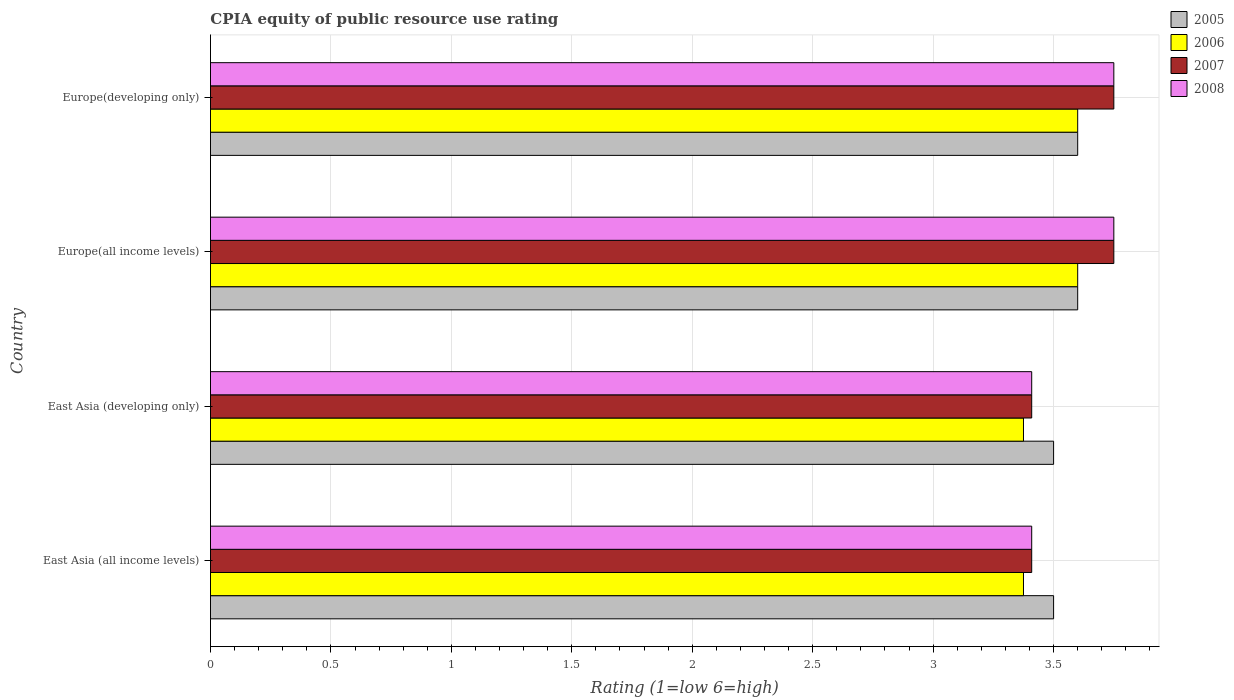How many groups of bars are there?
Ensure brevity in your answer.  4. How many bars are there on the 2nd tick from the bottom?
Your response must be concise. 4. What is the label of the 2nd group of bars from the top?
Your answer should be compact. Europe(all income levels). Across all countries, what is the minimum CPIA rating in 2005?
Ensure brevity in your answer.  3.5. In which country was the CPIA rating in 2005 maximum?
Provide a succinct answer. Europe(all income levels). In which country was the CPIA rating in 2006 minimum?
Your answer should be very brief. East Asia (all income levels). What is the total CPIA rating in 2007 in the graph?
Your answer should be very brief. 14.32. What is the difference between the CPIA rating in 2008 in Europe(all income levels) and that in Europe(developing only)?
Ensure brevity in your answer.  0. What is the average CPIA rating in 2008 per country?
Offer a terse response. 3.58. In how many countries, is the CPIA rating in 2005 greater than 1.9 ?
Your response must be concise. 4. What is the ratio of the CPIA rating in 2007 in East Asia (all income levels) to that in Europe(developing only)?
Keep it short and to the point. 0.91. Is the CPIA rating in 2005 in East Asia (all income levels) less than that in Europe(developing only)?
Your answer should be very brief. Yes. What is the difference between the highest and the second highest CPIA rating in 2005?
Your response must be concise. 0. What is the difference between the highest and the lowest CPIA rating in 2008?
Provide a short and direct response. 0.34. In how many countries, is the CPIA rating in 2006 greater than the average CPIA rating in 2006 taken over all countries?
Your answer should be very brief. 2. Is it the case that in every country, the sum of the CPIA rating in 2007 and CPIA rating in 2006 is greater than the sum of CPIA rating in 2008 and CPIA rating in 2005?
Offer a terse response. No. What does the 3rd bar from the bottom in Europe(all income levels) represents?
Keep it short and to the point. 2007. Is it the case that in every country, the sum of the CPIA rating in 2005 and CPIA rating in 2008 is greater than the CPIA rating in 2006?
Provide a succinct answer. Yes. Are all the bars in the graph horizontal?
Offer a terse response. Yes. What is the difference between two consecutive major ticks on the X-axis?
Provide a succinct answer. 0.5. Are the values on the major ticks of X-axis written in scientific E-notation?
Your answer should be very brief. No. Does the graph contain any zero values?
Your response must be concise. No. How many legend labels are there?
Offer a very short reply. 4. What is the title of the graph?
Your response must be concise. CPIA equity of public resource use rating. What is the label or title of the X-axis?
Offer a terse response. Rating (1=low 6=high). What is the Rating (1=low 6=high) of 2006 in East Asia (all income levels)?
Your response must be concise. 3.38. What is the Rating (1=low 6=high) of 2007 in East Asia (all income levels)?
Your answer should be very brief. 3.41. What is the Rating (1=low 6=high) of 2008 in East Asia (all income levels)?
Offer a very short reply. 3.41. What is the Rating (1=low 6=high) in 2006 in East Asia (developing only)?
Make the answer very short. 3.38. What is the Rating (1=low 6=high) in 2007 in East Asia (developing only)?
Ensure brevity in your answer.  3.41. What is the Rating (1=low 6=high) of 2008 in East Asia (developing only)?
Your answer should be compact. 3.41. What is the Rating (1=low 6=high) of 2006 in Europe(all income levels)?
Give a very brief answer. 3.6. What is the Rating (1=low 6=high) of 2007 in Europe(all income levels)?
Make the answer very short. 3.75. What is the Rating (1=low 6=high) in 2008 in Europe(all income levels)?
Give a very brief answer. 3.75. What is the Rating (1=low 6=high) of 2007 in Europe(developing only)?
Offer a terse response. 3.75. What is the Rating (1=low 6=high) in 2008 in Europe(developing only)?
Your answer should be compact. 3.75. Across all countries, what is the maximum Rating (1=low 6=high) in 2006?
Give a very brief answer. 3.6. Across all countries, what is the maximum Rating (1=low 6=high) in 2007?
Give a very brief answer. 3.75. Across all countries, what is the maximum Rating (1=low 6=high) of 2008?
Keep it short and to the point. 3.75. Across all countries, what is the minimum Rating (1=low 6=high) of 2006?
Keep it short and to the point. 3.38. Across all countries, what is the minimum Rating (1=low 6=high) of 2007?
Your response must be concise. 3.41. Across all countries, what is the minimum Rating (1=low 6=high) of 2008?
Ensure brevity in your answer.  3.41. What is the total Rating (1=low 6=high) of 2005 in the graph?
Keep it short and to the point. 14.2. What is the total Rating (1=low 6=high) of 2006 in the graph?
Provide a short and direct response. 13.95. What is the total Rating (1=low 6=high) in 2007 in the graph?
Your response must be concise. 14.32. What is the total Rating (1=low 6=high) in 2008 in the graph?
Ensure brevity in your answer.  14.32. What is the difference between the Rating (1=low 6=high) of 2006 in East Asia (all income levels) and that in Europe(all income levels)?
Give a very brief answer. -0.23. What is the difference between the Rating (1=low 6=high) in 2007 in East Asia (all income levels) and that in Europe(all income levels)?
Provide a short and direct response. -0.34. What is the difference between the Rating (1=low 6=high) of 2008 in East Asia (all income levels) and that in Europe(all income levels)?
Offer a very short reply. -0.34. What is the difference between the Rating (1=low 6=high) in 2006 in East Asia (all income levels) and that in Europe(developing only)?
Your answer should be compact. -0.23. What is the difference between the Rating (1=low 6=high) of 2007 in East Asia (all income levels) and that in Europe(developing only)?
Your answer should be very brief. -0.34. What is the difference between the Rating (1=low 6=high) of 2008 in East Asia (all income levels) and that in Europe(developing only)?
Offer a terse response. -0.34. What is the difference between the Rating (1=low 6=high) of 2005 in East Asia (developing only) and that in Europe(all income levels)?
Make the answer very short. -0.1. What is the difference between the Rating (1=low 6=high) of 2006 in East Asia (developing only) and that in Europe(all income levels)?
Make the answer very short. -0.23. What is the difference between the Rating (1=low 6=high) of 2007 in East Asia (developing only) and that in Europe(all income levels)?
Your answer should be compact. -0.34. What is the difference between the Rating (1=low 6=high) in 2008 in East Asia (developing only) and that in Europe(all income levels)?
Your answer should be very brief. -0.34. What is the difference between the Rating (1=low 6=high) of 2006 in East Asia (developing only) and that in Europe(developing only)?
Your response must be concise. -0.23. What is the difference between the Rating (1=low 6=high) in 2007 in East Asia (developing only) and that in Europe(developing only)?
Make the answer very short. -0.34. What is the difference between the Rating (1=low 6=high) of 2008 in East Asia (developing only) and that in Europe(developing only)?
Give a very brief answer. -0.34. What is the difference between the Rating (1=low 6=high) in 2005 in Europe(all income levels) and that in Europe(developing only)?
Keep it short and to the point. 0. What is the difference between the Rating (1=low 6=high) of 2007 in Europe(all income levels) and that in Europe(developing only)?
Ensure brevity in your answer.  0. What is the difference between the Rating (1=low 6=high) of 2005 in East Asia (all income levels) and the Rating (1=low 6=high) of 2007 in East Asia (developing only)?
Offer a very short reply. 0.09. What is the difference between the Rating (1=low 6=high) in 2005 in East Asia (all income levels) and the Rating (1=low 6=high) in 2008 in East Asia (developing only)?
Your response must be concise. 0.09. What is the difference between the Rating (1=low 6=high) of 2006 in East Asia (all income levels) and the Rating (1=low 6=high) of 2007 in East Asia (developing only)?
Provide a succinct answer. -0.03. What is the difference between the Rating (1=low 6=high) in 2006 in East Asia (all income levels) and the Rating (1=low 6=high) in 2008 in East Asia (developing only)?
Provide a short and direct response. -0.03. What is the difference between the Rating (1=low 6=high) of 2007 in East Asia (all income levels) and the Rating (1=low 6=high) of 2008 in East Asia (developing only)?
Your answer should be very brief. 0. What is the difference between the Rating (1=low 6=high) of 2005 in East Asia (all income levels) and the Rating (1=low 6=high) of 2006 in Europe(all income levels)?
Ensure brevity in your answer.  -0.1. What is the difference between the Rating (1=low 6=high) of 2005 in East Asia (all income levels) and the Rating (1=low 6=high) of 2007 in Europe(all income levels)?
Ensure brevity in your answer.  -0.25. What is the difference between the Rating (1=low 6=high) of 2006 in East Asia (all income levels) and the Rating (1=low 6=high) of 2007 in Europe(all income levels)?
Your response must be concise. -0.38. What is the difference between the Rating (1=low 6=high) of 2006 in East Asia (all income levels) and the Rating (1=low 6=high) of 2008 in Europe(all income levels)?
Your answer should be very brief. -0.38. What is the difference between the Rating (1=low 6=high) of 2007 in East Asia (all income levels) and the Rating (1=low 6=high) of 2008 in Europe(all income levels)?
Keep it short and to the point. -0.34. What is the difference between the Rating (1=low 6=high) of 2006 in East Asia (all income levels) and the Rating (1=low 6=high) of 2007 in Europe(developing only)?
Give a very brief answer. -0.38. What is the difference between the Rating (1=low 6=high) of 2006 in East Asia (all income levels) and the Rating (1=low 6=high) of 2008 in Europe(developing only)?
Your answer should be compact. -0.38. What is the difference between the Rating (1=low 6=high) in 2007 in East Asia (all income levels) and the Rating (1=low 6=high) in 2008 in Europe(developing only)?
Make the answer very short. -0.34. What is the difference between the Rating (1=low 6=high) of 2005 in East Asia (developing only) and the Rating (1=low 6=high) of 2006 in Europe(all income levels)?
Your answer should be compact. -0.1. What is the difference between the Rating (1=low 6=high) of 2005 in East Asia (developing only) and the Rating (1=low 6=high) of 2007 in Europe(all income levels)?
Ensure brevity in your answer.  -0.25. What is the difference between the Rating (1=low 6=high) of 2006 in East Asia (developing only) and the Rating (1=low 6=high) of 2007 in Europe(all income levels)?
Give a very brief answer. -0.38. What is the difference between the Rating (1=low 6=high) in 2006 in East Asia (developing only) and the Rating (1=low 6=high) in 2008 in Europe(all income levels)?
Your answer should be compact. -0.38. What is the difference between the Rating (1=low 6=high) of 2007 in East Asia (developing only) and the Rating (1=low 6=high) of 2008 in Europe(all income levels)?
Your answer should be very brief. -0.34. What is the difference between the Rating (1=low 6=high) in 2005 in East Asia (developing only) and the Rating (1=low 6=high) in 2006 in Europe(developing only)?
Your answer should be compact. -0.1. What is the difference between the Rating (1=low 6=high) in 2006 in East Asia (developing only) and the Rating (1=low 6=high) in 2007 in Europe(developing only)?
Provide a short and direct response. -0.38. What is the difference between the Rating (1=low 6=high) in 2006 in East Asia (developing only) and the Rating (1=low 6=high) in 2008 in Europe(developing only)?
Provide a succinct answer. -0.38. What is the difference between the Rating (1=low 6=high) in 2007 in East Asia (developing only) and the Rating (1=low 6=high) in 2008 in Europe(developing only)?
Your response must be concise. -0.34. What is the difference between the Rating (1=low 6=high) of 2006 in Europe(all income levels) and the Rating (1=low 6=high) of 2007 in Europe(developing only)?
Provide a short and direct response. -0.15. What is the difference between the Rating (1=low 6=high) of 2006 in Europe(all income levels) and the Rating (1=low 6=high) of 2008 in Europe(developing only)?
Your answer should be compact. -0.15. What is the average Rating (1=low 6=high) of 2005 per country?
Offer a very short reply. 3.55. What is the average Rating (1=low 6=high) of 2006 per country?
Provide a short and direct response. 3.49. What is the average Rating (1=low 6=high) in 2007 per country?
Offer a terse response. 3.58. What is the average Rating (1=low 6=high) in 2008 per country?
Your answer should be compact. 3.58. What is the difference between the Rating (1=low 6=high) in 2005 and Rating (1=low 6=high) in 2007 in East Asia (all income levels)?
Your answer should be very brief. 0.09. What is the difference between the Rating (1=low 6=high) of 2005 and Rating (1=low 6=high) of 2008 in East Asia (all income levels)?
Your answer should be compact. 0.09. What is the difference between the Rating (1=low 6=high) of 2006 and Rating (1=low 6=high) of 2007 in East Asia (all income levels)?
Offer a very short reply. -0.03. What is the difference between the Rating (1=low 6=high) in 2006 and Rating (1=low 6=high) in 2008 in East Asia (all income levels)?
Your answer should be very brief. -0.03. What is the difference between the Rating (1=low 6=high) in 2005 and Rating (1=low 6=high) in 2007 in East Asia (developing only)?
Make the answer very short. 0.09. What is the difference between the Rating (1=low 6=high) in 2005 and Rating (1=low 6=high) in 2008 in East Asia (developing only)?
Make the answer very short. 0.09. What is the difference between the Rating (1=low 6=high) in 2006 and Rating (1=low 6=high) in 2007 in East Asia (developing only)?
Provide a short and direct response. -0.03. What is the difference between the Rating (1=low 6=high) of 2006 and Rating (1=low 6=high) of 2008 in East Asia (developing only)?
Give a very brief answer. -0.03. What is the difference between the Rating (1=low 6=high) of 2005 and Rating (1=low 6=high) of 2007 in Europe(all income levels)?
Provide a succinct answer. -0.15. What is the difference between the Rating (1=low 6=high) in 2005 and Rating (1=low 6=high) in 2008 in Europe(all income levels)?
Offer a very short reply. -0.15. What is the difference between the Rating (1=low 6=high) in 2006 and Rating (1=low 6=high) in 2007 in Europe(all income levels)?
Offer a terse response. -0.15. What is the difference between the Rating (1=low 6=high) of 2005 and Rating (1=low 6=high) of 2006 in Europe(developing only)?
Your answer should be very brief. 0. What is the difference between the Rating (1=low 6=high) of 2005 and Rating (1=low 6=high) of 2007 in Europe(developing only)?
Your answer should be very brief. -0.15. What is the difference between the Rating (1=low 6=high) of 2007 and Rating (1=low 6=high) of 2008 in Europe(developing only)?
Offer a very short reply. 0. What is the ratio of the Rating (1=low 6=high) in 2006 in East Asia (all income levels) to that in East Asia (developing only)?
Your answer should be very brief. 1. What is the ratio of the Rating (1=low 6=high) of 2005 in East Asia (all income levels) to that in Europe(all income levels)?
Offer a very short reply. 0.97. What is the ratio of the Rating (1=low 6=high) of 2005 in East Asia (all income levels) to that in Europe(developing only)?
Ensure brevity in your answer.  0.97. What is the ratio of the Rating (1=low 6=high) in 2006 in East Asia (all income levels) to that in Europe(developing only)?
Offer a very short reply. 0.94. What is the ratio of the Rating (1=low 6=high) of 2007 in East Asia (all income levels) to that in Europe(developing only)?
Give a very brief answer. 0.91. What is the ratio of the Rating (1=low 6=high) in 2008 in East Asia (all income levels) to that in Europe(developing only)?
Keep it short and to the point. 0.91. What is the ratio of the Rating (1=low 6=high) in 2005 in East Asia (developing only) to that in Europe(all income levels)?
Keep it short and to the point. 0.97. What is the ratio of the Rating (1=low 6=high) in 2006 in East Asia (developing only) to that in Europe(all income levels)?
Your answer should be compact. 0.94. What is the ratio of the Rating (1=low 6=high) in 2008 in East Asia (developing only) to that in Europe(all income levels)?
Your answer should be very brief. 0.91. What is the ratio of the Rating (1=low 6=high) in 2005 in East Asia (developing only) to that in Europe(developing only)?
Your answer should be compact. 0.97. What is the ratio of the Rating (1=low 6=high) in 2006 in East Asia (developing only) to that in Europe(developing only)?
Provide a succinct answer. 0.94. What is the ratio of the Rating (1=low 6=high) of 2007 in East Asia (developing only) to that in Europe(developing only)?
Provide a short and direct response. 0.91. What is the ratio of the Rating (1=low 6=high) in 2007 in Europe(all income levels) to that in Europe(developing only)?
Make the answer very short. 1. What is the ratio of the Rating (1=low 6=high) of 2008 in Europe(all income levels) to that in Europe(developing only)?
Your answer should be compact. 1. What is the difference between the highest and the second highest Rating (1=low 6=high) of 2008?
Offer a terse response. 0. What is the difference between the highest and the lowest Rating (1=low 6=high) in 2006?
Offer a very short reply. 0.23. What is the difference between the highest and the lowest Rating (1=low 6=high) in 2007?
Ensure brevity in your answer.  0.34. What is the difference between the highest and the lowest Rating (1=low 6=high) in 2008?
Provide a succinct answer. 0.34. 